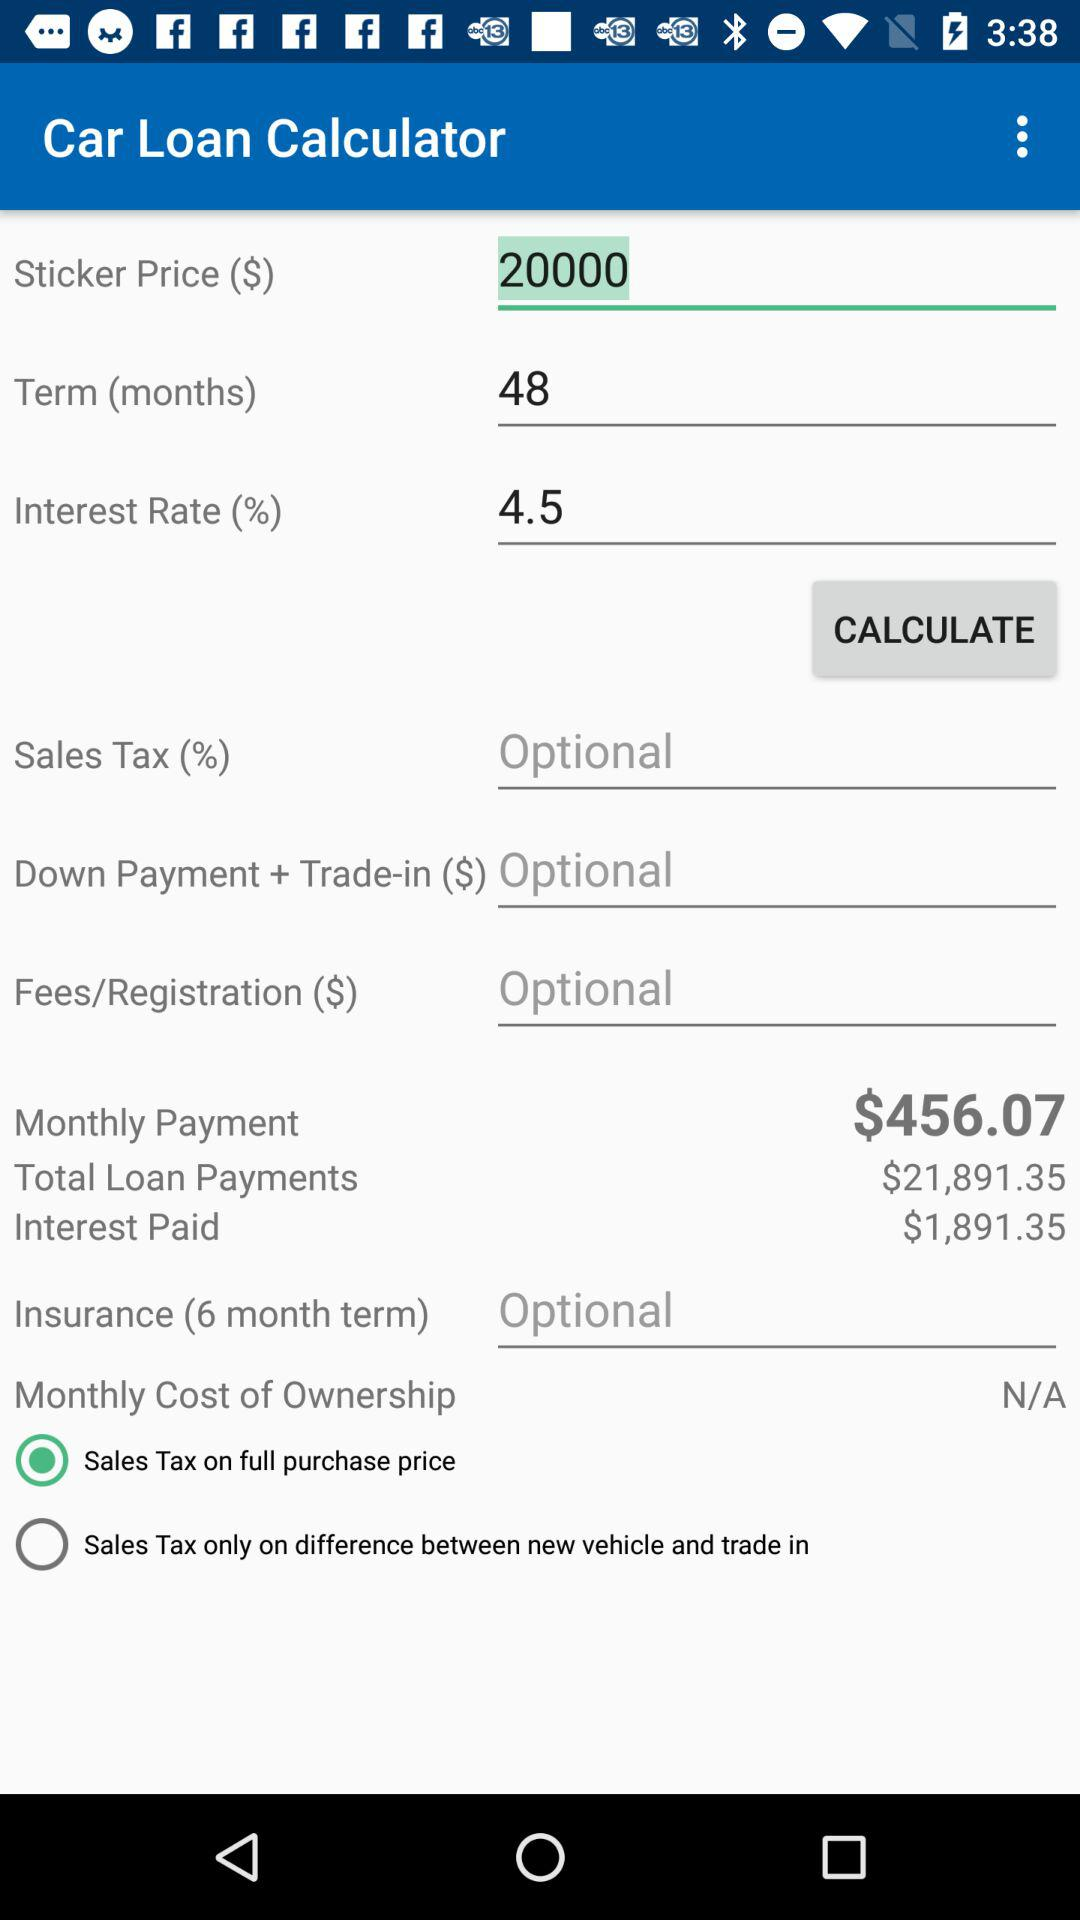What is the monthly payment for a 48 month loan at 4.5% interest on a $20,000 car?
Answer the question using a single word or phrase. $456.07 